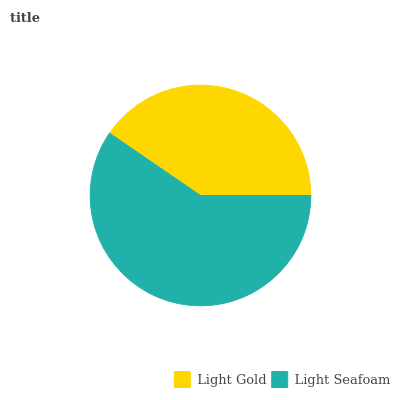Is Light Gold the minimum?
Answer yes or no. Yes. Is Light Seafoam the maximum?
Answer yes or no. Yes. Is Light Seafoam the minimum?
Answer yes or no. No. Is Light Seafoam greater than Light Gold?
Answer yes or no. Yes. Is Light Gold less than Light Seafoam?
Answer yes or no. Yes. Is Light Gold greater than Light Seafoam?
Answer yes or no. No. Is Light Seafoam less than Light Gold?
Answer yes or no. No. Is Light Seafoam the high median?
Answer yes or no. Yes. Is Light Gold the low median?
Answer yes or no. Yes. Is Light Gold the high median?
Answer yes or no. No. Is Light Seafoam the low median?
Answer yes or no. No. 